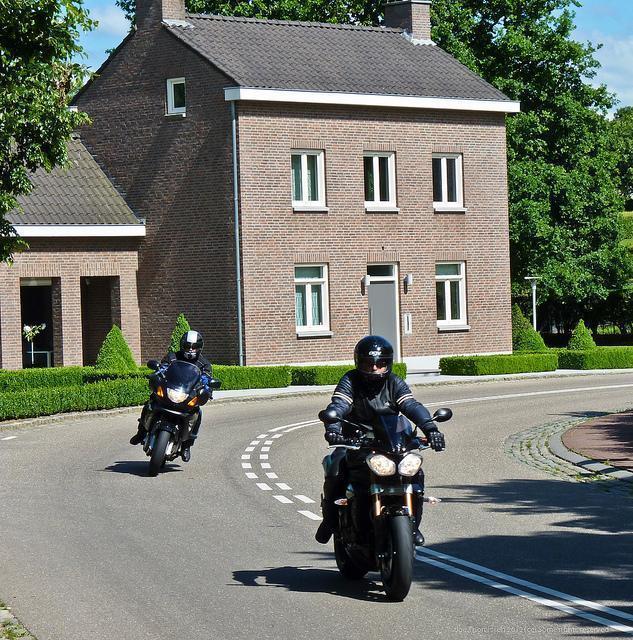What color are the stripes on the sleeves of the jacket worn by the motorcyclist in front?
Make your selection from the four choices given to correctly answer the question.
Options: Blue, white, green, red. White. 